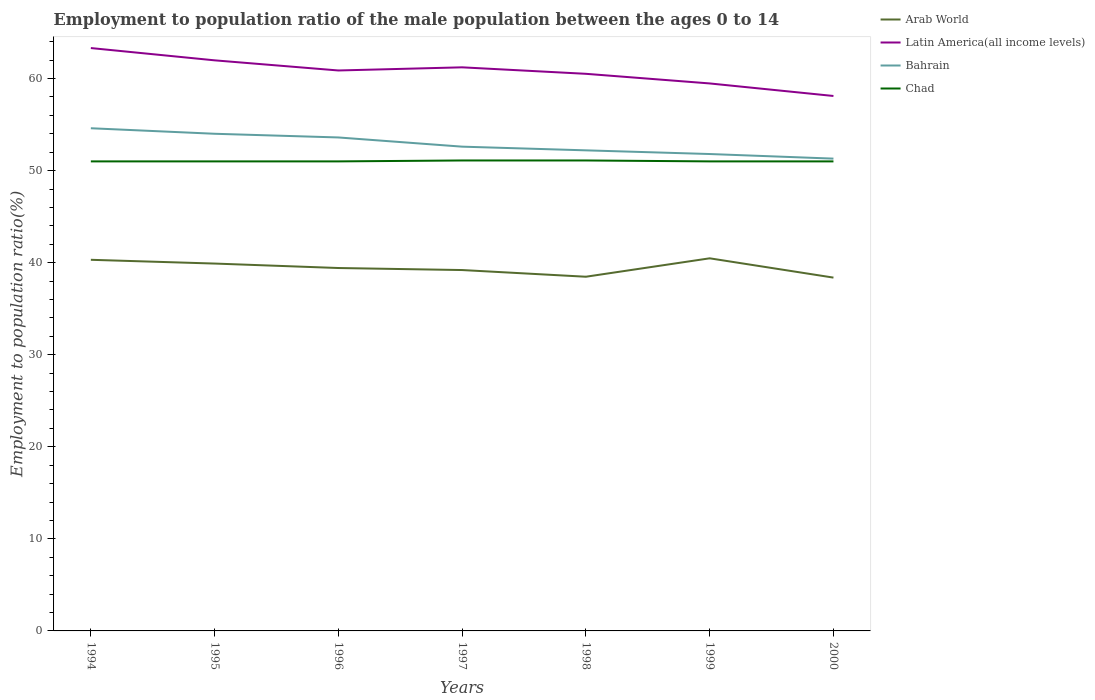How many different coloured lines are there?
Offer a terse response. 4. Is the number of lines equal to the number of legend labels?
Keep it short and to the point. Yes. What is the total employment to population ratio in Latin America(all income levels) in the graph?
Make the answer very short. 2.09. What is the difference between the highest and the second highest employment to population ratio in Bahrain?
Your answer should be very brief. 3.3. Is the employment to population ratio in Chad strictly greater than the employment to population ratio in Arab World over the years?
Offer a very short reply. No. How many lines are there?
Provide a short and direct response. 4. What is the difference between two consecutive major ticks on the Y-axis?
Offer a very short reply. 10. Are the values on the major ticks of Y-axis written in scientific E-notation?
Give a very brief answer. No. Does the graph contain any zero values?
Offer a terse response. No. What is the title of the graph?
Offer a terse response. Employment to population ratio of the male population between the ages 0 to 14. Does "Oman" appear as one of the legend labels in the graph?
Provide a succinct answer. No. What is the label or title of the X-axis?
Ensure brevity in your answer.  Years. What is the label or title of the Y-axis?
Ensure brevity in your answer.  Employment to population ratio(%). What is the Employment to population ratio(%) in Arab World in 1994?
Give a very brief answer. 40.31. What is the Employment to population ratio(%) of Latin America(all income levels) in 1994?
Offer a terse response. 63.31. What is the Employment to population ratio(%) in Bahrain in 1994?
Keep it short and to the point. 54.6. What is the Employment to population ratio(%) of Chad in 1994?
Your response must be concise. 51. What is the Employment to population ratio(%) of Arab World in 1995?
Keep it short and to the point. 39.9. What is the Employment to population ratio(%) in Latin America(all income levels) in 1995?
Provide a short and direct response. 61.98. What is the Employment to population ratio(%) of Bahrain in 1995?
Make the answer very short. 54. What is the Employment to population ratio(%) of Chad in 1995?
Offer a very short reply. 51. What is the Employment to population ratio(%) of Arab World in 1996?
Provide a short and direct response. 39.42. What is the Employment to population ratio(%) in Latin America(all income levels) in 1996?
Offer a terse response. 60.87. What is the Employment to population ratio(%) of Bahrain in 1996?
Give a very brief answer. 53.6. What is the Employment to population ratio(%) in Arab World in 1997?
Ensure brevity in your answer.  39.2. What is the Employment to population ratio(%) of Latin America(all income levels) in 1997?
Provide a short and direct response. 61.22. What is the Employment to population ratio(%) in Bahrain in 1997?
Your answer should be very brief. 52.6. What is the Employment to population ratio(%) in Chad in 1997?
Offer a terse response. 51.1. What is the Employment to population ratio(%) in Arab World in 1998?
Provide a short and direct response. 38.47. What is the Employment to population ratio(%) in Latin America(all income levels) in 1998?
Ensure brevity in your answer.  60.51. What is the Employment to population ratio(%) in Bahrain in 1998?
Give a very brief answer. 52.2. What is the Employment to population ratio(%) in Chad in 1998?
Give a very brief answer. 51.1. What is the Employment to population ratio(%) in Arab World in 1999?
Offer a terse response. 40.47. What is the Employment to population ratio(%) in Latin America(all income levels) in 1999?
Your answer should be very brief. 59.47. What is the Employment to population ratio(%) of Bahrain in 1999?
Your response must be concise. 51.8. What is the Employment to population ratio(%) in Arab World in 2000?
Your response must be concise. 38.38. What is the Employment to population ratio(%) in Latin America(all income levels) in 2000?
Give a very brief answer. 58.11. What is the Employment to population ratio(%) in Bahrain in 2000?
Your answer should be very brief. 51.3. Across all years, what is the maximum Employment to population ratio(%) in Arab World?
Your answer should be compact. 40.47. Across all years, what is the maximum Employment to population ratio(%) in Latin America(all income levels)?
Offer a terse response. 63.31. Across all years, what is the maximum Employment to population ratio(%) of Bahrain?
Provide a short and direct response. 54.6. Across all years, what is the maximum Employment to population ratio(%) in Chad?
Give a very brief answer. 51.1. Across all years, what is the minimum Employment to population ratio(%) of Arab World?
Offer a very short reply. 38.38. Across all years, what is the minimum Employment to population ratio(%) of Latin America(all income levels)?
Provide a short and direct response. 58.11. Across all years, what is the minimum Employment to population ratio(%) of Bahrain?
Your response must be concise. 51.3. Across all years, what is the minimum Employment to population ratio(%) in Chad?
Your response must be concise. 51. What is the total Employment to population ratio(%) in Arab World in the graph?
Give a very brief answer. 276.15. What is the total Employment to population ratio(%) of Latin America(all income levels) in the graph?
Your response must be concise. 425.46. What is the total Employment to population ratio(%) in Bahrain in the graph?
Keep it short and to the point. 370.1. What is the total Employment to population ratio(%) in Chad in the graph?
Provide a short and direct response. 357.2. What is the difference between the Employment to population ratio(%) of Arab World in 1994 and that in 1995?
Give a very brief answer. 0.41. What is the difference between the Employment to population ratio(%) in Latin America(all income levels) in 1994 and that in 1995?
Your answer should be compact. 1.33. What is the difference between the Employment to population ratio(%) of Bahrain in 1994 and that in 1995?
Keep it short and to the point. 0.6. What is the difference between the Employment to population ratio(%) in Arab World in 1994 and that in 1996?
Your response must be concise. 0.89. What is the difference between the Employment to population ratio(%) in Latin America(all income levels) in 1994 and that in 1996?
Make the answer very short. 2.44. What is the difference between the Employment to population ratio(%) of Arab World in 1994 and that in 1997?
Your answer should be very brief. 1.11. What is the difference between the Employment to population ratio(%) in Latin America(all income levels) in 1994 and that in 1997?
Provide a short and direct response. 2.09. What is the difference between the Employment to population ratio(%) in Bahrain in 1994 and that in 1997?
Make the answer very short. 2. What is the difference between the Employment to population ratio(%) in Chad in 1994 and that in 1997?
Your response must be concise. -0.1. What is the difference between the Employment to population ratio(%) of Arab World in 1994 and that in 1998?
Give a very brief answer. 1.84. What is the difference between the Employment to population ratio(%) of Latin America(all income levels) in 1994 and that in 1998?
Provide a short and direct response. 2.8. What is the difference between the Employment to population ratio(%) of Bahrain in 1994 and that in 1998?
Your answer should be very brief. 2.4. What is the difference between the Employment to population ratio(%) of Arab World in 1994 and that in 1999?
Offer a very short reply. -0.16. What is the difference between the Employment to population ratio(%) in Latin America(all income levels) in 1994 and that in 1999?
Provide a short and direct response. 3.84. What is the difference between the Employment to population ratio(%) of Arab World in 1994 and that in 2000?
Offer a very short reply. 1.93. What is the difference between the Employment to population ratio(%) in Latin America(all income levels) in 1994 and that in 2000?
Your answer should be compact. 5.21. What is the difference between the Employment to population ratio(%) in Bahrain in 1994 and that in 2000?
Your answer should be compact. 3.3. What is the difference between the Employment to population ratio(%) in Arab World in 1995 and that in 1996?
Your answer should be compact. 0.48. What is the difference between the Employment to population ratio(%) of Latin America(all income levels) in 1995 and that in 1996?
Your answer should be compact. 1.1. What is the difference between the Employment to population ratio(%) of Arab World in 1995 and that in 1997?
Make the answer very short. 0.7. What is the difference between the Employment to population ratio(%) in Latin America(all income levels) in 1995 and that in 1997?
Ensure brevity in your answer.  0.76. What is the difference between the Employment to population ratio(%) in Bahrain in 1995 and that in 1997?
Give a very brief answer. 1.4. What is the difference between the Employment to population ratio(%) in Chad in 1995 and that in 1997?
Provide a succinct answer. -0.1. What is the difference between the Employment to population ratio(%) in Arab World in 1995 and that in 1998?
Your answer should be very brief. 1.43. What is the difference between the Employment to population ratio(%) of Latin America(all income levels) in 1995 and that in 1998?
Ensure brevity in your answer.  1.46. What is the difference between the Employment to population ratio(%) in Arab World in 1995 and that in 1999?
Keep it short and to the point. -0.57. What is the difference between the Employment to population ratio(%) of Latin America(all income levels) in 1995 and that in 1999?
Offer a very short reply. 2.51. What is the difference between the Employment to population ratio(%) in Arab World in 1995 and that in 2000?
Give a very brief answer. 1.53. What is the difference between the Employment to population ratio(%) of Latin America(all income levels) in 1995 and that in 2000?
Keep it short and to the point. 3.87. What is the difference between the Employment to population ratio(%) in Bahrain in 1995 and that in 2000?
Your answer should be compact. 2.7. What is the difference between the Employment to population ratio(%) in Arab World in 1996 and that in 1997?
Your response must be concise. 0.22. What is the difference between the Employment to population ratio(%) in Latin America(all income levels) in 1996 and that in 1997?
Offer a terse response. -0.34. What is the difference between the Employment to population ratio(%) in Bahrain in 1996 and that in 1997?
Provide a succinct answer. 1. What is the difference between the Employment to population ratio(%) in Latin America(all income levels) in 1996 and that in 1998?
Your response must be concise. 0.36. What is the difference between the Employment to population ratio(%) in Chad in 1996 and that in 1998?
Ensure brevity in your answer.  -0.1. What is the difference between the Employment to population ratio(%) in Arab World in 1996 and that in 1999?
Your response must be concise. -1.05. What is the difference between the Employment to population ratio(%) in Latin America(all income levels) in 1996 and that in 1999?
Provide a succinct answer. 1.41. What is the difference between the Employment to population ratio(%) of Bahrain in 1996 and that in 1999?
Provide a succinct answer. 1.8. What is the difference between the Employment to population ratio(%) in Arab World in 1996 and that in 2000?
Give a very brief answer. 1.04. What is the difference between the Employment to population ratio(%) in Latin America(all income levels) in 1996 and that in 2000?
Offer a terse response. 2.77. What is the difference between the Employment to population ratio(%) in Bahrain in 1996 and that in 2000?
Provide a short and direct response. 2.3. What is the difference between the Employment to population ratio(%) of Chad in 1996 and that in 2000?
Keep it short and to the point. 0. What is the difference between the Employment to population ratio(%) of Arab World in 1997 and that in 1998?
Provide a succinct answer. 0.73. What is the difference between the Employment to population ratio(%) of Latin America(all income levels) in 1997 and that in 1998?
Give a very brief answer. 0.7. What is the difference between the Employment to population ratio(%) in Chad in 1997 and that in 1998?
Your response must be concise. 0. What is the difference between the Employment to population ratio(%) in Arab World in 1997 and that in 1999?
Offer a terse response. -1.27. What is the difference between the Employment to population ratio(%) of Latin America(all income levels) in 1997 and that in 1999?
Your answer should be compact. 1.75. What is the difference between the Employment to population ratio(%) in Bahrain in 1997 and that in 1999?
Make the answer very short. 0.8. What is the difference between the Employment to population ratio(%) of Chad in 1997 and that in 1999?
Your response must be concise. 0.1. What is the difference between the Employment to population ratio(%) in Arab World in 1997 and that in 2000?
Your answer should be very brief. 0.82. What is the difference between the Employment to population ratio(%) in Latin America(all income levels) in 1997 and that in 2000?
Offer a very short reply. 3.11. What is the difference between the Employment to population ratio(%) of Chad in 1997 and that in 2000?
Make the answer very short. 0.1. What is the difference between the Employment to population ratio(%) in Arab World in 1998 and that in 1999?
Give a very brief answer. -2. What is the difference between the Employment to population ratio(%) in Latin America(all income levels) in 1998 and that in 1999?
Make the answer very short. 1.05. What is the difference between the Employment to population ratio(%) in Bahrain in 1998 and that in 1999?
Your answer should be compact. 0.4. What is the difference between the Employment to population ratio(%) in Arab World in 1998 and that in 2000?
Give a very brief answer. 0.1. What is the difference between the Employment to population ratio(%) in Latin America(all income levels) in 1998 and that in 2000?
Provide a succinct answer. 2.41. What is the difference between the Employment to population ratio(%) in Bahrain in 1998 and that in 2000?
Your answer should be very brief. 0.9. What is the difference between the Employment to population ratio(%) in Chad in 1998 and that in 2000?
Give a very brief answer. 0.1. What is the difference between the Employment to population ratio(%) of Arab World in 1999 and that in 2000?
Ensure brevity in your answer.  2.1. What is the difference between the Employment to population ratio(%) of Latin America(all income levels) in 1999 and that in 2000?
Make the answer very short. 1.36. What is the difference between the Employment to population ratio(%) of Arab World in 1994 and the Employment to population ratio(%) of Latin America(all income levels) in 1995?
Give a very brief answer. -21.67. What is the difference between the Employment to population ratio(%) in Arab World in 1994 and the Employment to population ratio(%) in Bahrain in 1995?
Give a very brief answer. -13.69. What is the difference between the Employment to population ratio(%) in Arab World in 1994 and the Employment to population ratio(%) in Chad in 1995?
Give a very brief answer. -10.69. What is the difference between the Employment to population ratio(%) of Latin America(all income levels) in 1994 and the Employment to population ratio(%) of Bahrain in 1995?
Your answer should be compact. 9.31. What is the difference between the Employment to population ratio(%) in Latin America(all income levels) in 1994 and the Employment to population ratio(%) in Chad in 1995?
Provide a succinct answer. 12.31. What is the difference between the Employment to population ratio(%) in Arab World in 1994 and the Employment to population ratio(%) in Latin America(all income levels) in 1996?
Offer a terse response. -20.56. What is the difference between the Employment to population ratio(%) in Arab World in 1994 and the Employment to population ratio(%) in Bahrain in 1996?
Give a very brief answer. -13.29. What is the difference between the Employment to population ratio(%) of Arab World in 1994 and the Employment to population ratio(%) of Chad in 1996?
Provide a succinct answer. -10.69. What is the difference between the Employment to population ratio(%) in Latin America(all income levels) in 1994 and the Employment to population ratio(%) in Bahrain in 1996?
Keep it short and to the point. 9.71. What is the difference between the Employment to population ratio(%) in Latin America(all income levels) in 1994 and the Employment to population ratio(%) in Chad in 1996?
Your answer should be very brief. 12.31. What is the difference between the Employment to population ratio(%) of Bahrain in 1994 and the Employment to population ratio(%) of Chad in 1996?
Provide a short and direct response. 3.6. What is the difference between the Employment to population ratio(%) in Arab World in 1994 and the Employment to population ratio(%) in Latin America(all income levels) in 1997?
Make the answer very short. -20.91. What is the difference between the Employment to population ratio(%) of Arab World in 1994 and the Employment to population ratio(%) of Bahrain in 1997?
Provide a succinct answer. -12.29. What is the difference between the Employment to population ratio(%) of Arab World in 1994 and the Employment to population ratio(%) of Chad in 1997?
Provide a succinct answer. -10.79. What is the difference between the Employment to population ratio(%) in Latin America(all income levels) in 1994 and the Employment to population ratio(%) in Bahrain in 1997?
Make the answer very short. 10.71. What is the difference between the Employment to population ratio(%) in Latin America(all income levels) in 1994 and the Employment to population ratio(%) in Chad in 1997?
Ensure brevity in your answer.  12.21. What is the difference between the Employment to population ratio(%) of Bahrain in 1994 and the Employment to population ratio(%) of Chad in 1997?
Provide a succinct answer. 3.5. What is the difference between the Employment to population ratio(%) of Arab World in 1994 and the Employment to population ratio(%) of Latin America(all income levels) in 1998?
Offer a very short reply. -20.2. What is the difference between the Employment to population ratio(%) in Arab World in 1994 and the Employment to population ratio(%) in Bahrain in 1998?
Provide a short and direct response. -11.89. What is the difference between the Employment to population ratio(%) of Arab World in 1994 and the Employment to population ratio(%) of Chad in 1998?
Ensure brevity in your answer.  -10.79. What is the difference between the Employment to population ratio(%) of Latin America(all income levels) in 1994 and the Employment to population ratio(%) of Bahrain in 1998?
Your answer should be very brief. 11.11. What is the difference between the Employment to population ratio(%) of Latin America(all income levels) in 1994 and the Employment to population ratio(%) of Chad in 1998?
Give a very brief answer. 12.21. What is the difference between the Employment to population ratio(%) in Arab World in 1994 and the Employment to population ratio(%) in Latin America(all income levels) in 1999?
Your answer should be compact. -19.16. What is the difference between the Employment to population ratio(%) of Arab World in 1994 and the Employment to population ratio(%) of Bahrain in 1999?
Make the answer very short. -11.49. What is the difference between the Employment to population ratio(%) in Arab World in 1994 and the Employment to population ratio(%) in Chad in 1999?
Your answer should be very brief. -10.69. What is the difference between the Employment to population ratio(%) in Latin America(all income levels) in 1994 and the Employment to population ratio(%) in Bahrain in 1999?
Offer a very short reply. 11.51. What is the difference between the Employment to population ratio(%) in Latin America(all income levels) in 1994 and the Employment to population ratio(%) in Chad in 1999?
Provide a succinct answer. 12.31. What is the difference between the Employment to population ratio(%) in Bahrain in 1994 and the Employment to population ratio(%) in Chad in 1999?
Keep it short and to the point. 3.6. What is the difference between the Employment to population ratio(%) in Arab World in 1994 and the Employment to population ratio(%) in Latin America(all income levels) in 2000?
Make the answer very short. -17.79. What is the difference between the Employment to population ratio(%) in Arab World in 1994 and the Employment to population ratio(%) in Bahrain in 2000?
Offer a terse response. -10.99. What is the difference between the Employment to population ratio(%) in Arab World in 1994 and the Employment to population ratio(%) in Chad in 2000?
Offer a terse response. -10.69. What is the difference between the Employment to population ratio(%) in Latin America(all income levels) in 1994 and the Employment to population ratio(%) in Bahrain in 2000?
Make the answer very short. 12.01. What is the difference between the Employment to population ratio(%) in Latin America(all income levels) in 1994 and the Employment to population ratio(%) in Chad in 2000?
Your answer should be compact. 12.31. What is the difference between the Employment to population ratio(%) in Bahrain in 1994 and the Employment to population ratio(%) in Chad in 2000?
Offer a very short reply. 3.6. What is the difference between the Employment to population ratio(%) in Arab World in 1995 and the Employment to population ratio(%) in Latin America(all income levels) in 1996?
Your response must be concise. -20.97. What is the difference between the Employment to population ratio(%) in Arab World in 1995 and the Employment to population ratio(%) in Bahrain in 1996?
Provide a succinct answer. -13.7. What is the difference between the Employment to population ratio(%) of Arab World in 1995 and the Employment to population ratio(%) of Chad in 1996?
Give a very brief answer. -11.1. What is the difference between the Employment to population ratio(%) in Latin America(all income levels) in 1995 and the Employment to population ratio(%) in Bahrain in 1996?
Provide a short and direct response. 8.38. What is the difference between the Employment to population ratio(%) in Latin America(all income levels) in 1995 and the Employment to population ratio(%) in Chad in 1996?
Keep it short and to the point. 10.98. What is the difference between the Employment to population ratio(%) in Arab World in 1995 and the Employment to population ratio(%) in Latin America(all income levels) in 1997?
Provide a succinct answer. -21.31. What is the difference between the Employment to population ratio(%) in Arab World in 1995 and the Employment to population ratio(%) in Bahrain in 1997?
Ensure brevity in your answer.  -12.7. What is the difference between the Employment to population ratio(%) in Arab World in 1995 and the Employment to population ratio(%) in Chad in 1997?
Your answer should be compact. -11.2. What is the difference between the Employment to population ratio(%) of Latin America(all income levels) in 1995 and the Employment to population ratio(%) of Bahrain in 1997?
Your answer should be compact. 9.38. What is the difference between the Employment to population ratio(%) of Latin America(all income levels) in 1995 and the Employment to population ratio(%) of Chad in 1997?
Give a very brief answer. 10.88. What is the difference between the Employment to population ratio(%) in Bahrain in 1995 and the Employment to population ratio(%) in Chad in 1997?
Your answer should be very brief. 2.9. What is the difference between the Employment to population ratio(%) of Arab World in 1995 and the Employment to population ratio(%) of Latin America(all income levels) in 1998?
Your response must be concise. -20.61. What is the difference between the Employment to population ratio(%) of Arab World in 1995 and the Employment to population ratio(%) of Bahrain in 1998?
Offer a terse response. -12.3. What is the difference between the Employment to population ratio(%) in Arab World in 1995 and the Employment to population ratio(%) in Chad in 1998?
Offer a terse response. -11.2. What is the difference between the Employment to population ratio(%) in Latin America(all income levels) in 1995 and the Employment to population ratio(%) in Bahrain in 1998?
Provide a succinct answer. 9.78. What is the difference between the Employment to population ratio(%) of Latin America(all income levels) in 1995 and the Employment to population ratio(%) of Chad in 1998?
Provide a short and direct response. 10.88. What is the difference between the Employment to population ratio(%) in Bahrain in 1995 and the Employment to population ratio(%) in Chad in 1998?
Offer a very short reply. 2.9. What is the difference between the Employment to population ratio(%) in Arab World in 1995 and the Employment to population ratio(%) in Latin America(all income levels) in 1999?
Your answer should be very brief. -19.56. What is the difference between the Employment to population ratio(%) of Arab World in 1995 and the Employment to population ratio(%) of Bahrain in 1999?
Ensure brevity in your answer.  -11.9. What is the difference between the Employment to population ratio(%) of Arab World in 1995 and the Employment to population ratio(%) of Chad in 1999?
Offer a terse response. -11.1. What is the difference between the Employment to population ratio(%) of Latin America(all income levels) in 1995 and the Employment to population ratio(%) of Bahrain in 1999?
Ensure brevity in your answer.  10.18. What is the difference between the Employment to population ratio(%) of Latin America(all income levels) in 1995 and the Employment to population ratio(%) of Chad in 1999?
Keep it short and to the point. 10.98. What is the difference between the Employment to population ratio(%) of Arab World in 1995 and the Employment to population ratio(%) of Latin America(all income levels) in 2000?
Give a very brief answer. -18.2. What is the difference between the Employment to population ratio(%) in Arab World in 1995 and the Employment to population ratio(%) in Bahrain in 2000?
Keep it short and to the point. -11.4. What is the difference between the Employment to population ratio(%) in Arab World in 1995 and the Employment to population ratio(%) in Chad in 2000?
Provide a short and direct response. -11.1. What is the difference between the Employment to population ratio(%) in Latin America(all income levels) in 1995 and the Employment to population ratio(%) in Bahrain in 2000?
Provide a succinct answer. 10.68. What is the difference between the Employment to population ratio(%) in Latin America(all income levels) in 1995 and the Employment to population ratio(%) in Chad in 2000?
Ensure brevity in your answer.  10.98. What is the difference between the Employment to population ratio(%) of Bahrain in 1995 and the Employment to population ratio(%) of Chad in 2000?
Make the answer very short. 3. What is the difference between the Employment to population ratio(%) of Arab World in 1996 and the Employment to population ratio(%) of Latin America(all income levels) in 1997?
Offer a terse response. -21.8. What is the difference between the Employment to population ratio(%) in Arab World in 1996 and the Employment to population ratio(%) in Bahrain in 1997?
Provide a succinct answer. -13.18. What is the difference between the Employment to population ratio(%) of Arab World in 1996 and the Employment to population ratio(%) of Chad in 1997?
Your response must be concise. -11.68. What is the difference between the Employment to population ratio(%) of Latin America(all income levels) in 1996 and the Employment to population ratio(%) of Bahrain in 1997?
Your response must be concise. 8.27. What is the difference between the Employment to population ratio(%) of Latin America(all income levels) in 1996 and the Employment to population ratio(%) of Chad in 1997?
Your answer should be compact. 9.77. What is the difference between the Employment to population ratio(%) of Arab World in 1996 and the Employment to population ratio(%) of Latin America(all income levels) in 1998?
Offer a terse response. -21.09. What is the difference between the Employment to population ratio(%) of Arab World in 1996 and the Employment to population ratio(%) of Bahrain in 1998?
Ensure brevity in your answer.  -12.78. What is the difference between the Employment to population ratio(%) in Arab World in 1996 and the Employment to population ratio(%) in Chad in 1998?
Your answer should be very brief. -11.68. What is the difference between the Employment to population ratio(%) of Latin America(all income levels) in 1996 and the Employment to population ratio(%) of Bahrain in 1998?
Ensure brevity in your answer.  8.67. What is the difference between the Employment to population ratio(%) of Latin America(all income levels) in 1996 and the Employment to population ratio(%) of Chad in 1998?
Your answer should be very brief. 9.77. What is the difference between the Employment to population ratio(%) in Bahrain in 1996 and the Employment to population ratio(%) in Chad in 1998?
Your answer should be compact. 2.5. What is the difference between the Employment to population ratio(%) in Arab World in 1996 and the Employment to population ratio(%) in Latin America(all income levels) in 1999?
Provide a succinct answer. -20.05. What is the difference between the Employment to population ratio(%) of Arab World in 1996 and the Employment to population ratio(%) of Bahrain in 1999?
Your answer should be very brief. -12.38. What is the difference between the Employment to population ratio(%) in Arab World in 1996 and the Employment to population ratio(%) in Chad in 1999?
Your answer should be very brief. -11.58. What is the difference between the Employment to population ratio(%) of Latin America(all income levels) in 1996 and the Employment to population ratio(%) of Bahrain in 1999?
Ensure brevity in your answer.  9.07. What is the difference between the Employment to population ratio(%) of Latin America(all income levels) in 1996 and the Employment to population ratio(%) of Chad in 1999?
Ensure brevity in your answer.  9.87. What is the difference between the Employment to population ratio(%) of Arab World in 1996 and the Employment to population ratio(%) of Latin America(all income levels) in 2000?
Provide a short and direct response. -18.69. What is the difference between the Employment to population ratio(%) in Arab World in 1996 and the Employment to population ratio(%) in Bahrain in 2000?
Keep it short and to the point. -11.88. What is the difference between the Employment to population ratio(%) in Arab World in 1996 and the Employment to population ratio(%) in Chad in 2000?
Keep it short and to the point. -11.58. What is the difference between the Employment to population ratio(%) in Latin America(all income levels) in 1996 and the Employment to population ratio(%) in Bahrain in 2000?
Offer a very short reply. 9.57. What is the difference between the Employment to population ratio(%) in Latin America(all income levels) in 1996 and the Employment to population ratio(%) in Chad in 2000?
Offer a terse response. 9.87. What is the difference between the Employment to population ratio(%) of Arab World in 1997 and the Employment to population ratio(%) of Latin America(all income levels) in 1998?
Your answer should be very brief. -21.31. What is the difference between the Employment to population ratio(%) of Arab World in 1997 and the Employment to population ratio(%) of Bahrain in 1998?
Your answer should be compact. -13. What is the difference between the Employment to population ratio(%) of Arab World in 1997 and the Employment to population ratio(%) of Chad in 1998?
Your answer should be very brief. -11.9. What is the difference between the Employment to population ratio(%) in Latin America(all income levels) in 1997 and the Employment to population ratio(%) in Bahrain in 1998?
Keep it short and to the point. 9.02. What is the difference between the Employment to population ratio(%) of Latin America(all income levels) in 1997 and the Employment to population ratio(%) of Chad in 1998?
Your answer should be compact. 10.12. What is the difference between the Employment to population ratio(%) of Bahrain in 1997 and the Employment to population ratio(%) of Chad in 1998?
Give a very brief answer. 1.5. What is the difference between the Employment to population ratio(%) in Arab World in 1997 and the Employment to population ratio(%) in Latin America(all income levels) in 1999?
Your response must be concise. -20.27. What is the difference between the Employment to population ratio(%) of Arab World in 1997 and the Employment to population ratio(%) of Bahrain in 1999?
Your answer should be compact. -12.6. What is the difference between the Employment to population ratio(%) of Arab World in 1997 and the Employment to population ratio(%) of Chad in 1999?
Your answer should be very brief. -11.8. What is the difference between the Employment to population ratio(%) in Latin America(all income levels) in 1997 and the Employment to population ratio(%) in Bahrain in 1999?
Provide a succinct answer. 9.42. What is the difference between the Employment to population ratio(%) in Latin America(all income levels) in 1997 and the Employment to population ratio(%) in Chad in 1999?
Offer a terse response. 10.22. What is the difference between the Employment to population ratio(%) of Bahrain in 1997 and the Employment to population ratio(%) of Chad in 1999?
Your response must be concise. 1.6. What is the difference between the Employment to population ratio(%) of Arab World in 1997 and the Employment to population ratio(%) of Latin America(all income levels) in 2000?
Provide a succinct answer. -18.91. What is the difference between the Employment to population ratio(%) in Arab World in 1997 and the Employment to population ratio(%) in Bahrain in 2000?
Offer a terse response. -12.1. What is the difference between the Employment to population ratio(%) of Arab World in 1997 and the Employment to population ratio(%) of Chad in 2000?
Your answer should be compact. -11.8. What is the difference between the Employment to population ratio(%) of Latin America(all income levels) in 1997 and the Employment to population ratio(%) of Bahrain in 2000?
Ensure brevity in your answer.  9.92. What is the difference between the Employment to population ratio(%) in Latin America(all income levels) in 1997 and the Employment to population ratio(%) in Chad in 2000?
Your answer should be very brief. 10.22. What is the difference between the Employment to population ratio(%) in Bahrain in 1997 and the Employment to population ratio(%) in Chad in 2000?
Provide a succinct answer. 1.6. What is the difference between the Employment to population ratio(%) of Arab World in 1998 and the Employment to population ratio(%) of Latin America(all income levels) in 1999?
Offer a terse response. -21. What is the difference between the Employment to population ratio(%) in Arab World in 1998 and the Employment to population ratio(%) in Bahrain in 1999?
Give a very brief answer. -13.33. What is the difference between the Employment to population ratio(%) in Arab World in 1998 and the Employment to population ratio(%) in Chad in 1999?
Ensure brevity in your answer.  -12.53. What is the difference between the Employment to population ratio(%) in Latin America(all income levels) in 1998 and the Employment to population ratio(%) in Bahrain in 1999?
Give a very brief answer. 8.71. What is the difference between the Employment to population ratio(%) in Latin America(all income levels) in 1998 and the Employment to population ratio(%) in Chad in 1999?
Offer a very short reply. 9.51. What is the difference between the Employment to population ratio(%) in Bahrain in 1998 and the Employment to population ratio(%) in Chad in 1999?
Your answer should be compact. 1.2. What is the difference between the Employment to population ratio(%) in Arab World in 1998 and the Employment to population ratio(%) in Latin America(all income levels) in 2000?
Make the answer very short. -19.63. What is the difference between the Employment to population ratio(%) in Arab World in 1998 and the Employment to population ratio(%) in Bahrain in 2000?
Ensure brevity in your answer.  -12.83. What is the difference between the Employment to population ratio(%) in Arab World in 1998 and the Employment to population ratio(%) in Chad in 2000?
Ensure brevity in your answer.  -12.53. What is the difference between the Employment to population ratio(%) of Latin America(all income levels) in 1998 and the Employment to population ratio(%) of Bahrain in 2000?
Your answer should be very brief. 9.21. What is the difference between the Employment to population ratio(%) in Latin America(all income levels) in 1998 and the Employment to population ratio(%) in Chad in 2000?
Offer a terse response. 9.51. What is the difference between the Employment to population ratio(%) in Arab World in 1999 and the Employment to population ratio(%) in Latin America(all income levels) in 2000?
Your response must be concise. -17.63. What is the difference between the Employment to population ratio(%) of Arab World in 1999 and the Employment to population ratio(%) of Bahrain in 2000?
Your response must be concise. -10.83. What is the difference between the Employment to population ratio(%) of Arab World in 1999 and the Employment to population ratio(%) of Chad in 2000?
Make the answer very short. -10.53. What is the difference between the Employment to population ratio(%) of Latin America(all income levels) in 1999 and the Employment to population ratio(%) of Bahrain in 2000?
Offer a very short reply. 8.17. What is the difference between the Employment to population ratio(%) in Latin America(all income levels) in 1999 and the Employment to population ratio(%) in Chad in 2000?
Your answer should be compact. 8.47. What is the average Employment to population ratio(%) in Arab World per year?
Give a very brief answer. 39.45. What is the average Employment to population ratio(%) in Latin America(all income levels) per year?
Offer a very short reply. 60.78. What is the average Employment to population ratio(%) of Bahrain per year?
Provide a succinct answer. 52.87. What is the average Employment to population ratio(%) of Chad per year?
Ensure brevity in your answer.  51.03. In the year 1994, what is the difference between the Employment to population ratio(%) of Arab World and Employment to population ratio(%) of Latin America(all income levels)?
Ensure brevity in your answer.  -23. In the year 1994, what is the difference between the Employment to population ratio(%) of Arab World and Employment to population ratio(%) of Bahrain?
Make the answer very short. -14.29. In the year 1994, what is the difference between the Employment to population ratio(%) of Arab World and Employment to population ratio(%) of Chad?
Your response must be concise. -10.69. In the year 1994, what is the difference between the Employment to population ratio(%) of Latin America(all income levels) and Employment to population ratio(%) of Bahrain?
Give a very brief answer. 8.71. In the year 1994, what is the difference between the Employment to population ratio(%) in Latin America(all income levels) and Employment to population ratio(%) in Chad?
Make the answer very short. 12.31. In the year 1995, what is the difference between the Employment to population ratio(%) of Arab World and Employment to population ratio(%) of Latin America(all income levels)?
Your response must be concise. -22.07. In the year 1995, what is the difference between the Employment to population ratio(%) in Arab World and Employment to population ratio(%) in Bahrain?
Keep it short and to the point. -14.1. In the year 1995, what is the difference between the Employment to population ratio(%) of Arab World and Employment to population ratio(%) of Chad?
Give a very brief answer. -11.1. In the year 1995, what is the difference between the Employment to population ratio(%) in Latin America(all income levels) and Employment to population ratio(%) in Bahrain?
Give a very brief answer. 7.98. In the year 1995, what is the difference between the Employment to population ratio(%) of Latin America(all income levels) and Employment to population ratio(%) of Chad?
Offer a very short reply. 10.98. In the year 1996, what is the difference between the Employment to population ratio(%) of Arab World and Employment to population ratio(%) of Latin America(all income levels)?
Your response must be concise. -21.46. In the year 1996, what is the difference between the Employment to population ratio(%) in Arab World and Employment to population ratio(%) in Bahrain?
Your answer should be compact. -14.18. In the year 1996, what is the difference between the Employment to population ratio(%) in Arab World and Employment to population ratio(%) in Chad?
Your answer should be compact. -11.58. In the year 1996, what is the difference between the Employment to population ratio(%) in Latin America(all income levels) and Employment to population ratio(%) in Bahrain?
Provide a succinct answer. 7.27. In the year 1996, what is the difference between the Employment to population ratio(%) in Latin America(all income levels) and Employment to population ratio(%) in Chad?
Offer a terse response. 9.87. In the year 1997, what is the difference between the Employment to population ratio(%) of Arab World and Employment to population ratio(%) of Latin America(all income levels)?
Offer a very short reply. -22.02. In the year 1997, what is the difference between the Employment to population ratio(%) in Arab World and Employment to population ratio(%) in Bahrain?
Give a very brief answer. -13.4. In the year 1997, what is the difference between the Employment to population ratio(%) of Arab World and Employment to population ratio(%) of Chad?
Give a very brief answer. -11.9. In the year 1997, what is the difference between the Employment to population ratio(%) of Latin America(all income levels) and Employment to population ratio(%) of Bahrain?
Your response must be concise. 8.62. In the year 1997, what is the difference between the Employment to population ratio(%) in Latin America(all income levels) and Employment to population ratio(%) in Chad?
Your response must be concise. 10.12. In the year 1998, what is the difference between the Employment to population ratio(%) of Arab World and Employment to population ratio(%) of Latin America(all income levels)?
Ensure brevity in your answer.  -22.04. In the year 1998, what is the difference between the Employment to population ratio(%) in Arab World and Employment to population ratio(%) in Bahrain?
Your answer should be compact. -13.73. In the year 1998, what is the difference between the Employment to population ratio(%) of Arab World and Employment to population ratio(%) of Chad?
Make the answer very short. -12.63. In the year 1998, what is the difference between the Employment to population ratio(%) in Latin America(all income levels) and Employment to population ratio(%) in Bahrain?
Make the answer very short. 8.31. In the year 1998, what is the difference between the Employment to population ratio(%) in Latin America(all income levels) and Employment to population ratio(%) in Chad?
Your response must be concise. 9.41. In the year 1998, what is the difference between the Employment to population ratio(%) of Bahrain and Employment to population ratio(%) of Chad?
Keep it short and to the point. 1.1. In the year 1999, what is the difference between the Employment to population ratio(%) of Arab World and Employment to population ratio(%) of Latin America(all income levels)?
Give a very brief answer. -18.99. In the year 1999, what is the difference between the Employment to population ratio(%) of Arab World and Employment to population ratio(%) of Bahrain?
Offer a terse response. -11.33. In the year 1999, what is the difference between the Employment to population ratio(%) of Arab World and Employment to population ratio(%) of Chad?
Keep it short and to the point. -10.53. In the year 1999, what is the difference between the Employment to population ratio(%) in Latin America(all income levels) and Employment to population ratio(%) in Bahrain?
Your answer should be compact. 7.67. In the year 1999, what is the difference between the Employment to population ratio(%) in Latin America(all income levels) and Employment to population ratio(%) in Chad?
Ensure brevity in your answer.  8.47. In the year 1999, what is the difference between the Employment to population ratio(%) of Bahrain and Employment to population ratio(%) of Chad?
Ensure brevity in your answer.  0.8. In the year 2000, what is the difference between the Employment to population ratio(%) in Arab World and Employment to population ratio(%) in Latin America(all income levels)?
Make the answer very short. -19.73. In the year 2000, what is the difference between the Employment to population ratio(%) in Arab World and Employment to population ratio(%) in Bahrain?
Make the answer very short. -12.92. In the year 2000, what is the difference between the Employment to population ratio(%) in Arab World and Employment to population ratio(%) in Chad?
Your response must be concise. -12.62. In the year 2000, what is the difference between the Employment to population ratio(%) in Latin America(all income levels) and Employment to population ratio(%) in Bahrain?
Offer a very short reply. 6.8. In the year 2000, what is the difference between the Employment to population ratio(%) of Latin America(all income levels) and Employment to population ratio(%) of Chad?
Ensure brevity in your answer.  7.11. In the year 2000, what is the difference between the Employment to population ratio(%) in Bahrain and Employment to population ratio(%) in Chad?
Your response must be concise. 0.3. What is the ratio of the Employment to population ratio(%) in Arab World in 1994 to that in 1995?
Keep it short and to the point. 1.01. What is the ratio of the Employment to population ratio(%) in Latin America(all income levels) in 1994 to that in 1995?
Your response must be concise. 1.02. What is the ratio of the Employment to population ratio(%) of Bahrain in 1994 to that in 1995?
Give a very brief answer. 1.01. What is the ratio of the Employment to population ratio(%) of Arab World in 1994 to that in 1996?
Your answer should be very brief. 1.02. What is the ratio of the Employment to population ratio(%) of Latin America(all income levels) in 1994 to that in 1996?
Make the answer very short. 1.04. What is the ratio of the Employment to population ratio(%) of Bahrain in 1994 to that in 1996?
Provide a succinct answer. 1.02. What is the ratio of the Employment to population ratio(%) in Arab World in 1994 to that in 1997?
Offer a very short reply. 1.03. What is the ratio of the Employment to population ratio(%) in Latin America(all income levels) in 1994 to that in 1997?
Make the answer very short. 1.03. What is the ratio of the Employment to population ratio(%) of Bahrain in 1994 to that in 1997?
Your answer should be compact. 1.04. What is the ratio of the Employment to population ratio(%) in Arab World in 1994 to that in 1998?
Keep it short and to the point. 1.05. What is the ratio of the Employment to population ratio(%) in Latin America(all income levels) in 1994 to that in 1998?
Provide a succinct answer. 1.05. What is the ratio of the Employment to population ratio(%) in Bahrain in 1994 to that in 1998?
Your answer should be compact. 1.05. What is the ratio of the Employment to population ratio(%) of Latin America(all income levels) in 1994 to that in 1999?
Give a very brief answer. 1.06. What is the ratio of the Employment to population ratio(%) in Bahrain in 1994 to that in 1999?
Give a very brief answer. 1.05. What is the ratio of the Employment to population ratio(%) of Chad in 1994 to that in 1999?
Make the answer very short. 1. What is the ratio of the Employment to population ratio(%) of Arab World in 1994 to that in 2000?
Provide a succinct answer. 1.05. What is the ratio of the Employment to population ratio(%) in Latin America(all income levels) in 1994 to that in 2000?
Provide a succinct answer. 1.09. What is the ratio of the Employment to population ratio(%) of Bahrain in 1994 to that in 2000?
Provide a succinct answer. 1.06. What is the ratio of the Employment to population ratio(%) of Chad in 1994 to that in 2000?
Your answer should be compact. 1. What is the ratio of the Employment to population ratio(%) in Arab World in 1995 to that in 1996?
Your answer should be compact. 1.01. What is the ratio of the Employment to population ratio(%) in Latin America(all income levels) in 1995 to that in 1996?
Offer a very short reply. 1.02. What is the ratio of the Employment to population ratio(%) of Bahrain in 1995 to that in 1996?
Offer a very short reply. 1.01. What is the ratio of the Employment to population ratio(%) of Arab World in 1995 to that in 1997?
Provide a short and direct response. 1.02. What is the ratio of the Employment to population ratio(%) of Latin America(all income levels) in 1995 to that in 1997?
Offer a terse response. 1.01. What is the ratio of the Employment to population ratio(%) in Bahrain in 1995 to that in 1997?
Your answer should be very brief. 1.03. What is the ratio of the Employment to population ratio(%) in Arab World in 1995 to that in 1998?
Keep it short and to the point. 1.04. What is the ratio of the Employment to population ratio(%) in Latin America(all income levels) in 1995 to that in 1998?
Give a very brief answer. 1.02. What is the ratio of the Employment to population ratio(%) in Bahrain in 1995 to that in 1998?
Offer a terse response. 1.03. What is the ratio of the Employment to population ratio(%) in Arab World in 1995 to that in 1999?
Give a very brief answer. 0.99. What is the ratio of the Employment to population ratio(%) of Latin America(all income levels) in 1995 to that in 1999?
Give a very brief answer. 1.04. What is the ratio of the Employment to population ratio(%) in Bahrain in 1995 to that in 1999?
Provide a succinct answer. 1.04. What is the ratio of the Employment to population ratio(%) in Arab World in 1995 to that in 2000?
Ensure brevity in your answer.  1.04. What is the ratio of the Employment to population ratio(%) of Latin America(all income levels) in 1995 to that in 2000?
Offer a terse response. 1.07. What is the ratio of the Employment to population ratio(%) in Bahrain in 1995 to that in 2000?
Give a very brief answer. 1.05. What is the ratio of the Employment to population ratio(%) of Chad in 1995 to that in 2000?
Offer a terse response. 1. What is the ratio of the Employment to population ratio(%) in Arab World in 1996 to that in 1997?
Your answer should be very brief. 1.01. What is the ratio of the Employment to population ratio(%) in Bahrain in 1996 to that in 1997?
Provide a short and direct response. 1.02. What is the ratio of the Employment to population ratio(%) in Chad in 1996 to that in 1997?
Your answer should be compact. 1. What is the ratio of the Employment to population ratio(%) of Arab World in 1996 to that in 1998?
Your response must be concise. 1.02. What is the ratio of the Employment to population ratio(%) of Bahrain in 1996 to that in 1998?
Provide a succinct answer. 1.03. What is the ratio of the Employment to population ratio(%) of Chad in 1996 to that in 1998?
Ensure brevity in your answer.  1. What is the ratio of the Employment to population ratio(%) in Arab World in 1996 to that in 1999?
Provide a short and direct response. 0.97. What is the ratio of the Employment to population ratio(%) in Latin America(all income levels) in 1996 to that in 1999?
Your answer should be very brief. 1.02. What is the ratio of the Employment to population ratio(%) of Bahrain in 1996 to that in 1999?
Your response must be concise. 1.03. What is the ratio of the Employment to population ratio(%) of Chad in 1996 to that in 1999?
Provide a short and direct response. 1. What is the ratio of the Employment to population ratio(%) of Arab World in 1996 to that in 2000?
Keep it short and to the point. 1.03. What is the ratio of the Employment to population ratio(%) in Latin America(all income levels) in 1996 to that in 2000?
Make the answer very short. 1.05. What is the ratio of the Employment to population ratio(%) of Bahrain in 1996 to that in 2000?
Your response must be concise. 1.04. What is the ratio of the Employment to population ratio(%) of Arab World in 1997 to that in 1998?
Give a very brief answer. 1.02. What is the ratio of the Employment to population ratio(%) of Latin America(all income levels) in 1997 to that in 1998?
Your answer should be very brief. 1.01. What is the ratio of the Employment to population ratio(%) of Bahrain in 1997 to that in 1998?
Provide a succinct answer. 1.01. What is the ratio of the Employment to population ratio(%) in Arab World in 1997 to that in 1999?
Make the answer very short. 0.97. What is the ratio of the Employment to population ratio(%) of Latin America(all income levels) in 1997 to that in 1999?
Provide a short and direct response. 1.03. What is the ratio of the Employment to population ratio(%) of Bahrain in 1997 to that in 1999?
Your answer should be compact. 1.02. What is the ratio of the Employment to population ratio(%) of Chad in 1997 to that in 1999?
Provide a short and direct response. 1. What is the ratio of the Employment to population ratio(%) of Arab World in 1997 to that in 2000?
Offer a terse response. 1.02. What is the ratio of the Employment to population ratio(%) of Latin America(all income levels) in 1997 to that in 2000?
Provide a short and direct response. 1.05. What is the ratio of the Employment to population ratio(%) in Bahrain in 1997 to that in 2000?
Make the answer very short. 1.03. What is the ratio of the Employment to population ratio(%) in Arab World in 1998 to that in 1999?
Ensure brevity in your answer.  0.95. What is the ratio of the Employment to population ratio(%) of Latin America(all income levels) in 1998 to that in 1999?
Give a very brief answer. 1.02. What is the ratio of the Employment to population ratio(%) of Bahrain in 1998 to that in 1999?
Keep it short and to the point. 1.01. What is the ratio of the Employment to population ratio(%) of Chad in 1998 to that in 1999?
Your response must be concise. 1. What is the ratio of the Employment to population ratio(%) in Arab World in 1998 to that in 2000?
Give a very brief answer. 1. What is the ratio of the Employment to population ratio(%) in Latin America(all income levels) in 1998 to that in 2000?
Provide a succinct answer. 1.04. What is the ratio of the Employment to population ratio(%) in Bahrain in 1998 to that in 2000?
Your answer should be very brief. 1.02. What is the ratio of the Employment to population ratio(%) in Chad in 1998 to that in 2000?
Ensure brevity in your answer.  1. What is the ratio of the Employment to population ratio(%) of Arab World in 1999 to that in 2000?
Provide a succinct answer. 1.05. What is the ratio of the Employment to population ratio(%) of Latin America(all income levels) in 1999 to that in 2000?
Give a very brief answer. 1.02. What is the ratio of the Employment to population ratio(%) in Bahrain in 1999 to that in 2000?
Provide a short and direct response. 1.01. What is the difference between the highest and the second highest Employment to population ratio(%) in Arab World?
Your answer should be very brief. 0.16. What is the difference between the highest and the second highest Employment to population ratio(%) in Latin America(all income levels)?
Keep it short and to the point. 1.33. What is the difference between the highest and the second highest Employment to population ratio(%) in Bahrain?
Offer a very short reply. 0.6. What is the difference between the highest and the lowest Employment to population ratio(%) of Arab World?
Offer a very short reply. 2.1. What is the difference between the highest and the lowest Employment to population ratio(%) in Latin America(all income levels)?
Offer a very short reply. 5.21. 